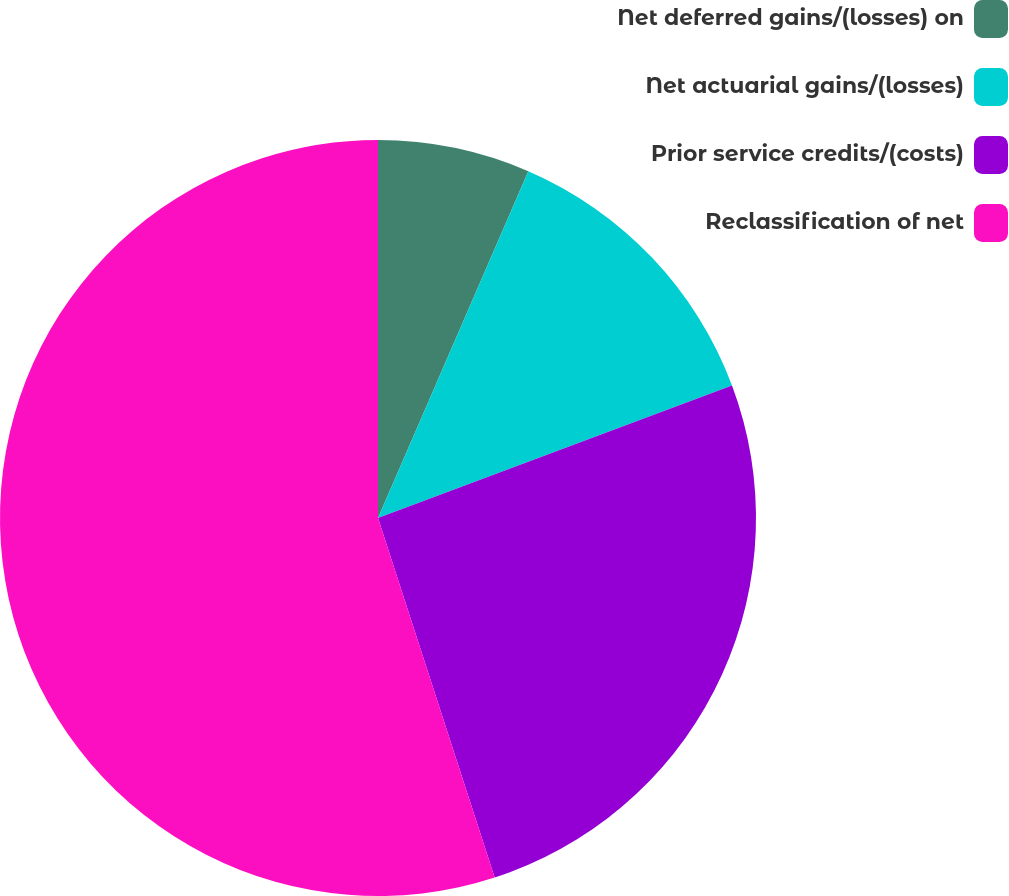<chart> <loc_0><loc_0><loc_500><loc_500><pie_chart><fcel>Net deferred gains/(losses) on<fcel>Net actuarial gains/(losses)<fcel>Prior service credits/(costs)<fcel>Reclassification of net<nl><fcel>6.51%<fcel>12.79%<fcel>25.71%<fcel>55.0%<nl></chart> 